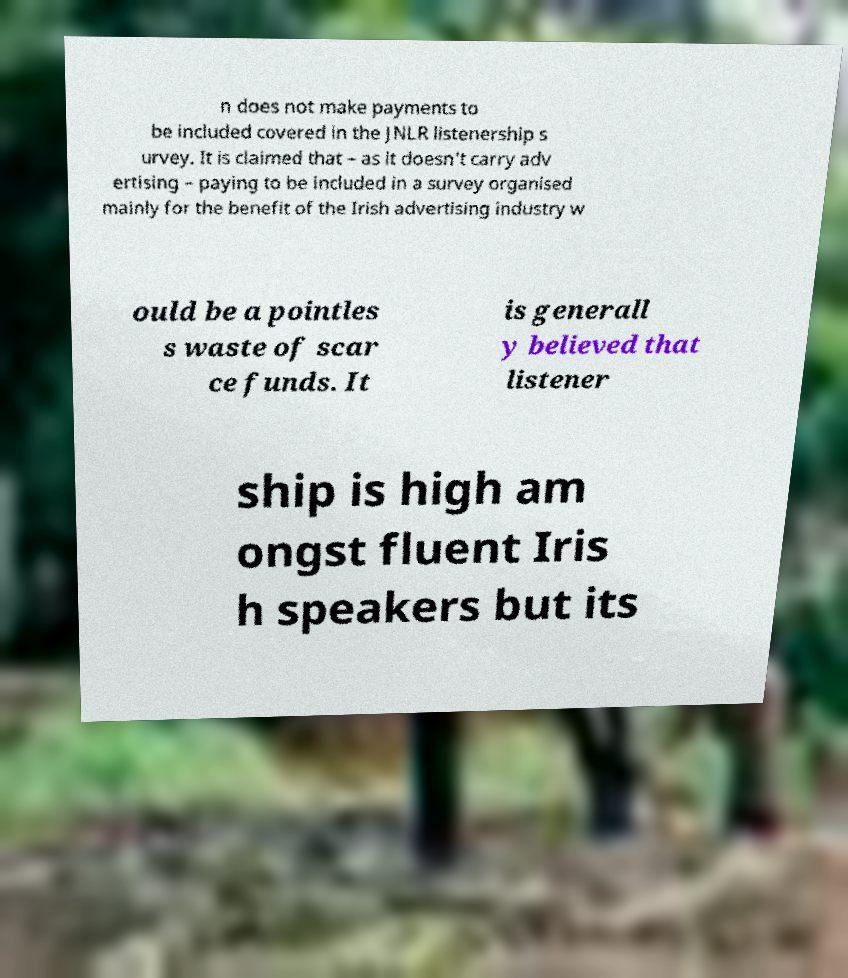What messages or text are displayed in this image? I need them in a readable, typed format. n does not make payments to be included covered in the JNLR listenership s urvey. It is claimed that – as it doesn't carry adv ertising – paying to be included in a survey organised mainly for the benefit of the Irish advertising industry w ould be a pointles s waste of scar ce funds. It is generall y believed that listener ship is high am ongst fluent Iris h speakers but its 